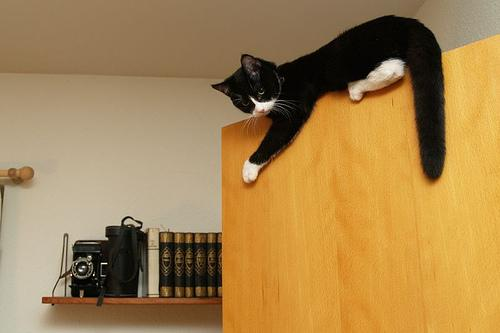What old device can be seen on the left end of the shelf? Please explain your reasoning. camera. A black, small object with a lens is on a shelf. cameras have lenses. 